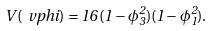<formula> <loc_0><loc_0><loc_500><loc_500>V ( \ v p h i ) = 1 6 \, ( 1 - \phi _ { 3 } ^ { 2 } ) ( 1 - \phi _ { 1 } ^ { 2 } ) .</formula> 